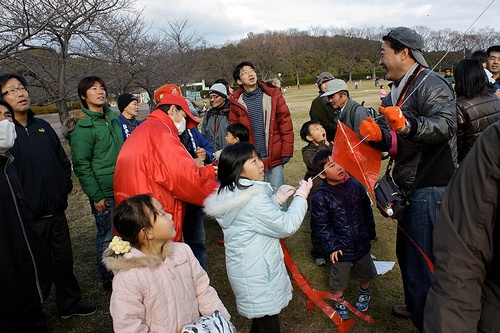Describe the objects in this image and their specific colors. I can see people in gray, black, darkgray, and navy tones, people in gray, black, darkgray, and maroon tones, people in gray, darkgray, black, and lightgray tones, people in gray and black tones, and people in gray, lightgray, lightblue, darkgray, and black tones in this image. 